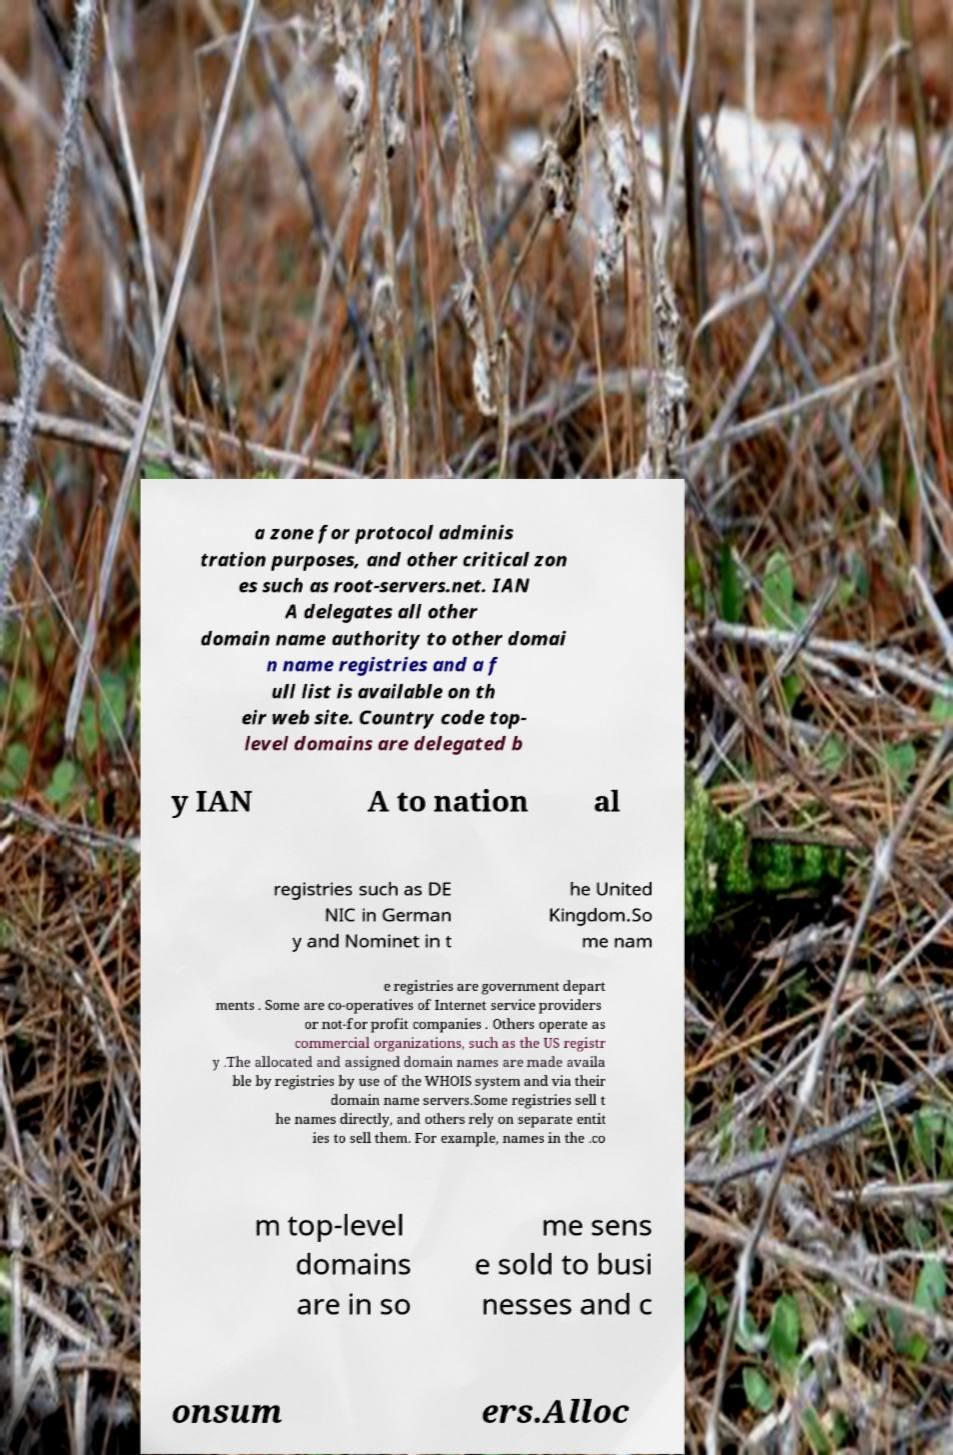I need the written content from this picture converted into text. Can you do that? a zone for protocol adminis tration purposes, and other critical zon es such as root-servers.net. IAN A delegates all other domain name authority to other domai n name registries and a f ull list is available on th eir web site. Country code top- level domains are delegated b y IAN A to nation al registries such as DE NIC in German y and Nominet in t he United Kingdom.So me nam e registries are government depart ments . Some are co-operatives of Internet service providers or not-for profit companies . Others operate as commercial organizations, such as the US registr y .The allocated and assigned domain names are made availa ble by registries by use of the WHOIS system and via their domain name servers.Some registries sell t he names directly, and others rely on separate entit ies to sell them. For example, names in the .co m top-level domains are in so me sens e sold to busi nesses and c onsum ers.Alloc 